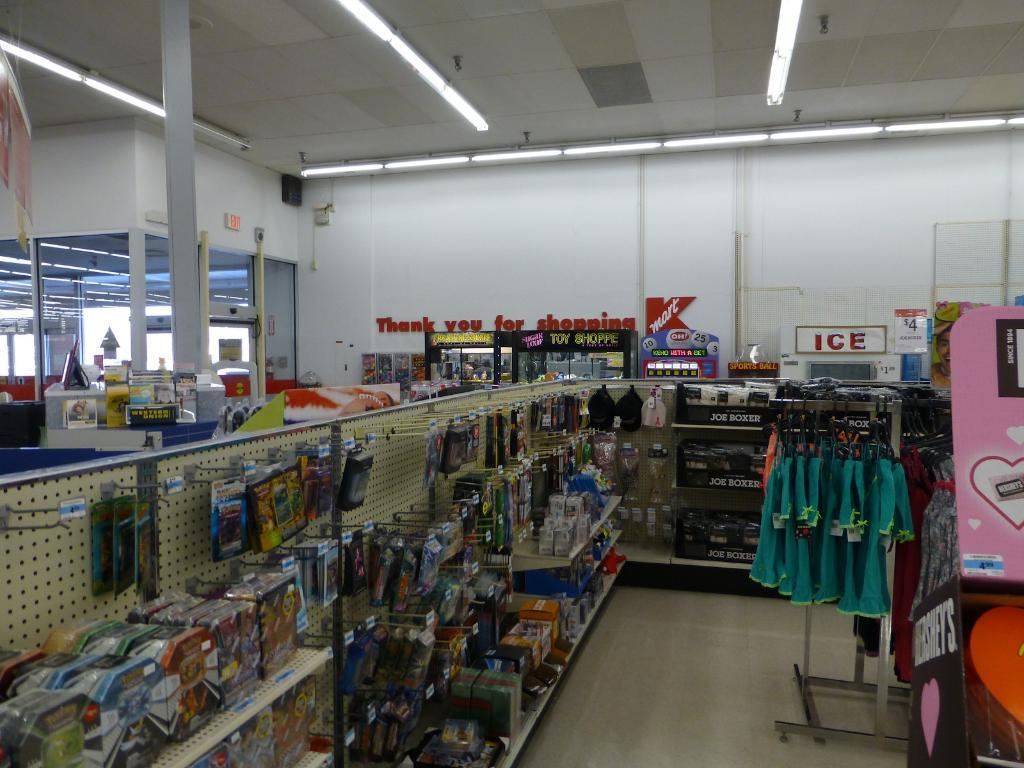Provide a one-sentence caption for the provided image. A display of goods for sale in Kmart. 